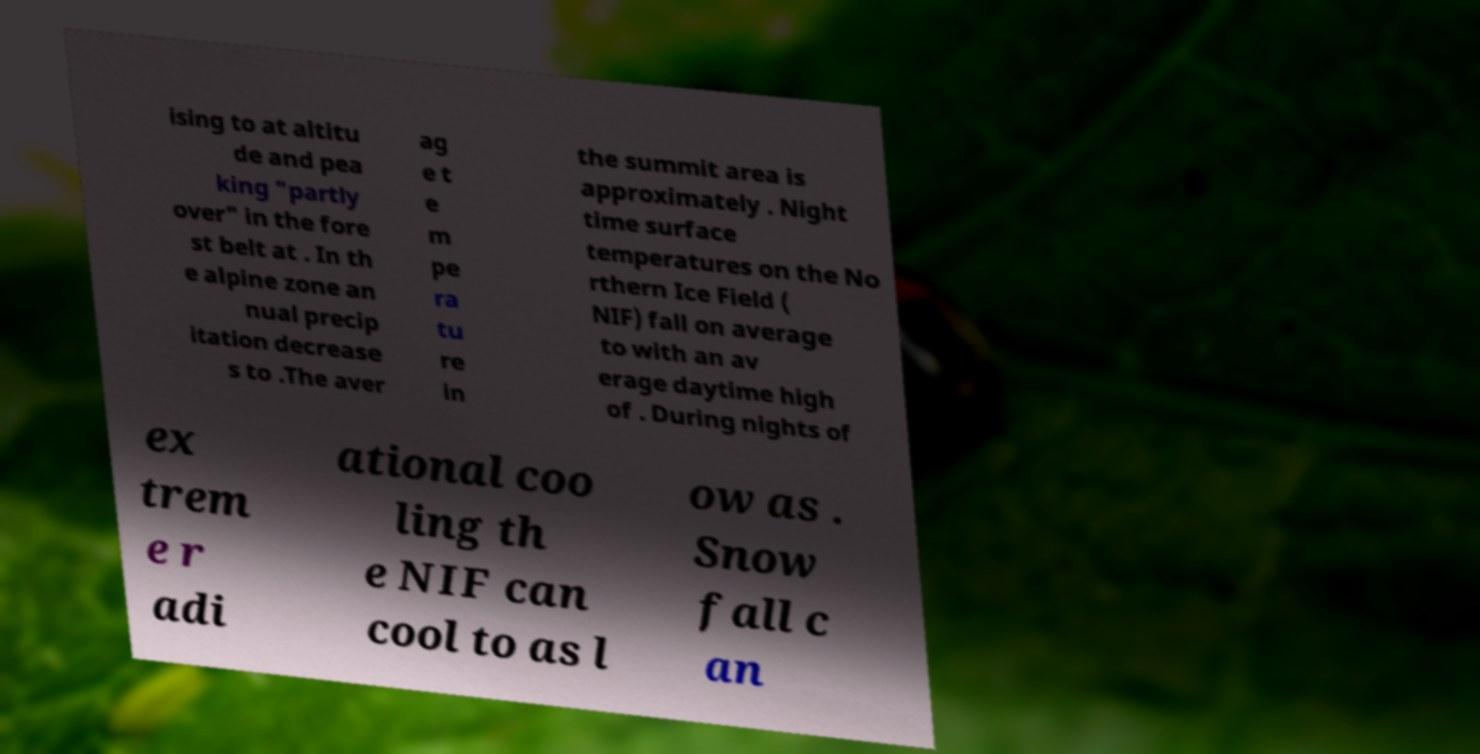What messages or text are displayed in this image? I need them in a readable, typed format. ising to at altitu de and pea king "partly over" in the fore st belt at . In th e alpine zone an nual precip itation decrease s to .The aver ag e t e m pe ra tu re in the summit area is approximately . Night time surface temperatures on the No rthern Ice Field ( NIF) fall on average to with an av erage daytime high of . During nights of ex trem e r adi ational coo ling th e NIF can cool to as l ow as . Snow fall c an 